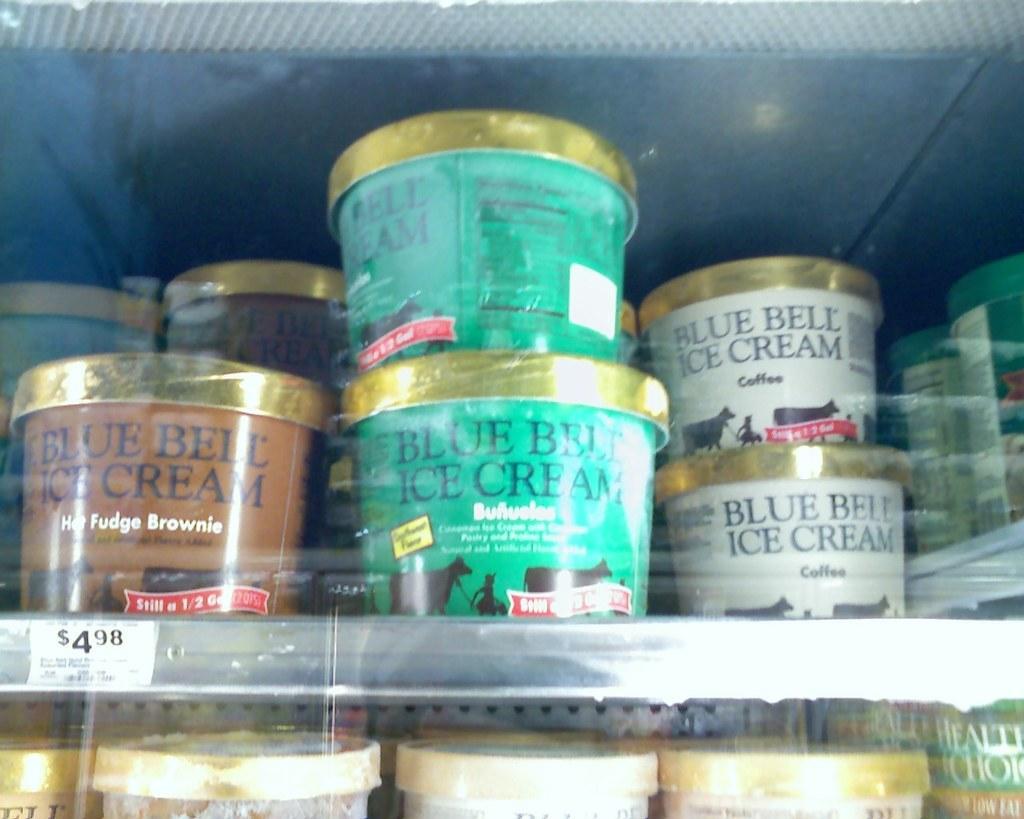Can you describe this image briefly? In this image I can see few boxes are arranged in the racks. On the boxes, I can see some text. 